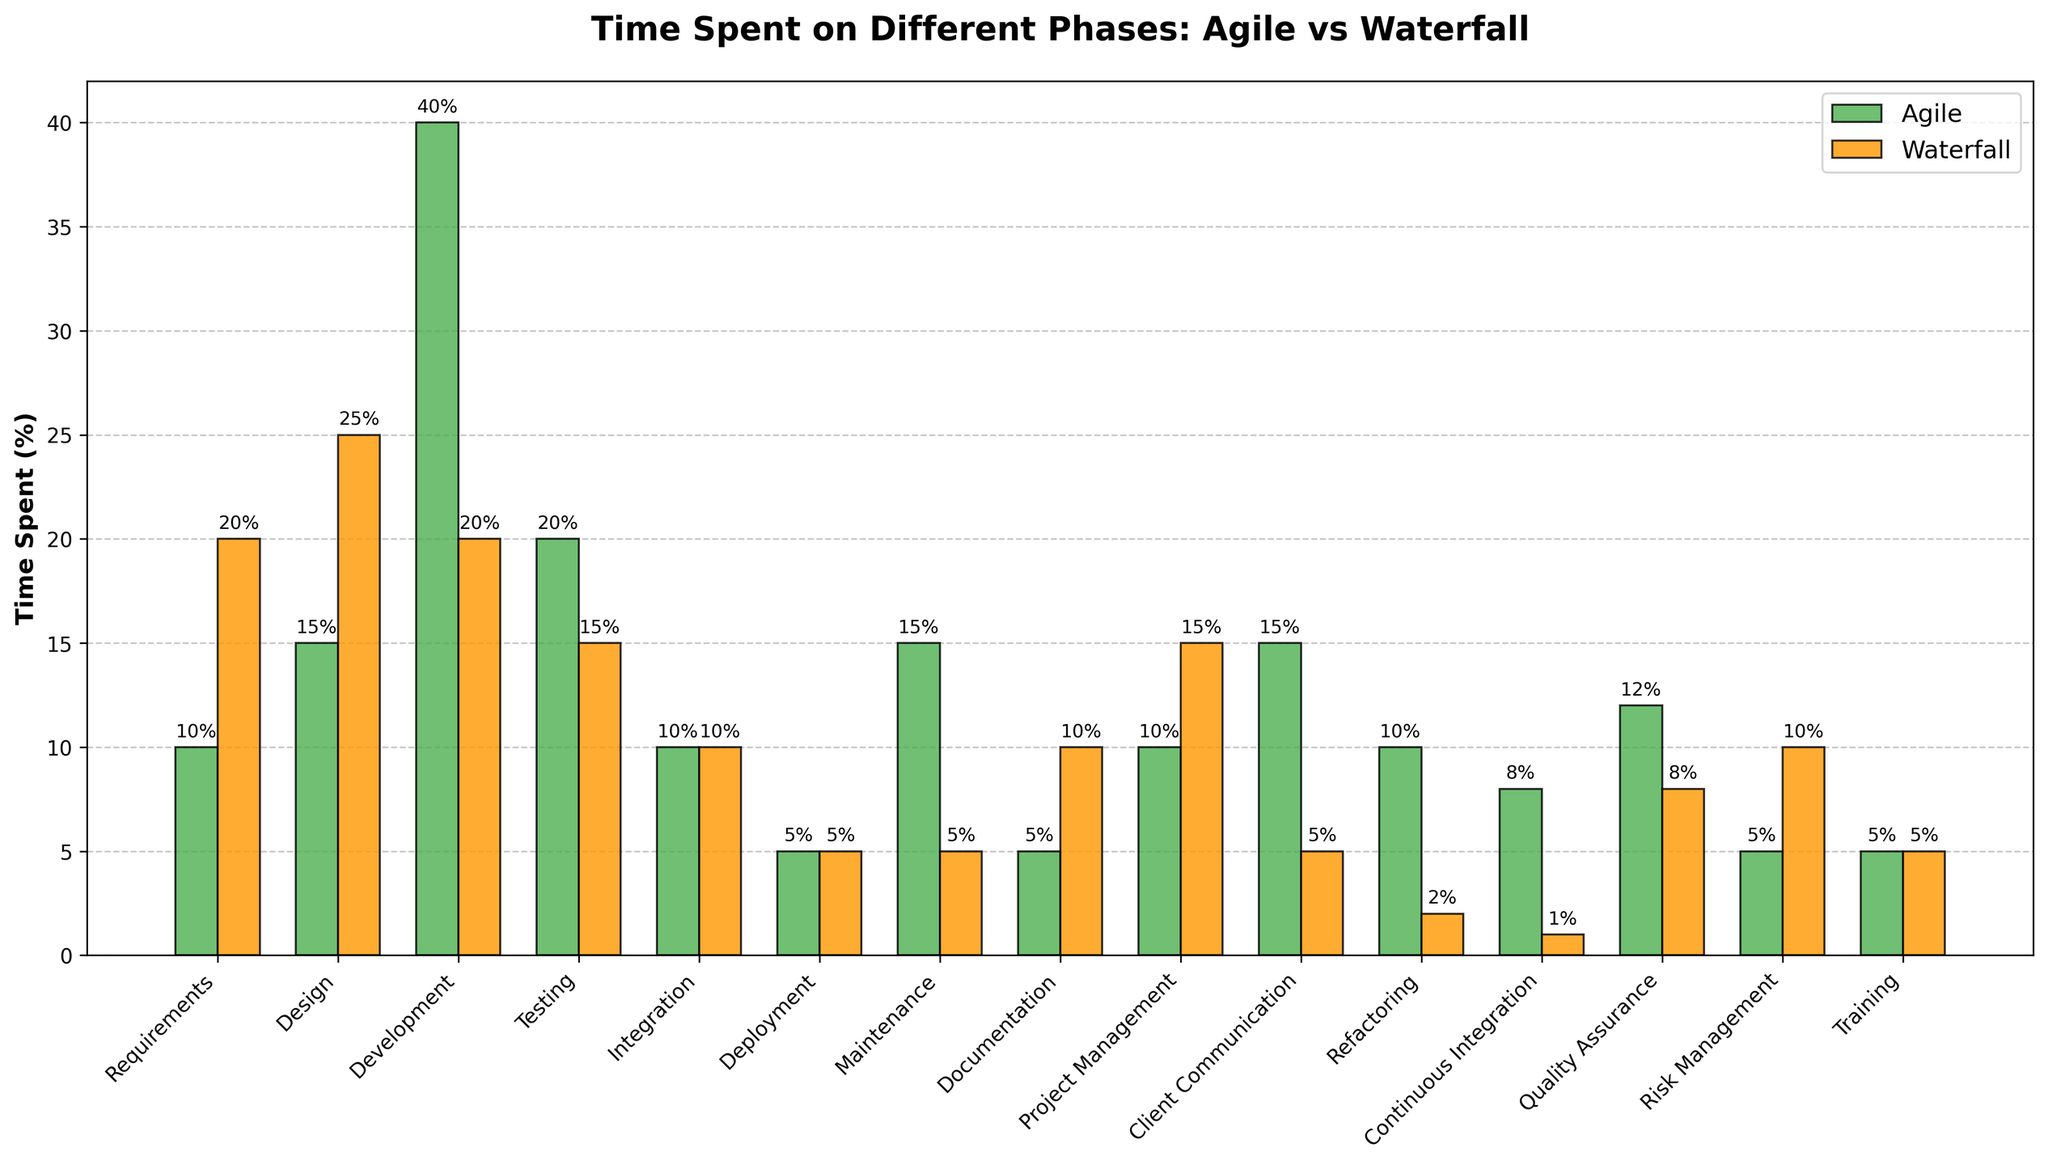Which phase spends the least amount of time in Agile? Looking at the bars for Agile (colored green), the shortest bar is for the Deployment phase.
Answer: Deployment Which methodology spends more time on Design? Comparing the Design phase bars, the bar for Waterfall (orange) is taller than the bar for Agile (green).
Answer: Waterfall How much more time is spent on Maintenance in Agile compared to Waterfall? The Agile bar for Maintenance shows 15%, while the Waterfall bar shows 5%. The difference is 15% - 5%.
Answer: 10% Which phase has equal time spent in both methodologies? The Integration and Deployment phases have bars of the same height for Agile and Waterfall.
Answer: Integration and Deployment What is the total percentage of time spent on Development and Testing in Agile? Adding the values from the Agile bars for Development (40%) and Testing (20%) gives 40% + 20%.
Answer: 60% Which methodology allocates more time to Risk Management? The Risk Management phase bar for Waterfall (orange) is taller than the Agile bar (green).
Answer: Waterfall How much more time is spent on Documentation in Waterfall compared to Agile? The Agile bar for Documentation shows 5%, while the Waterfall bar shows 10%. The difference is 10% - 5%.
Answer: 5% Which phase has the most significant allocation of time in Agile? The Agile bar for Development is the tallest at 40%, indicating the highest time allocation.
Answer: Development How much time is spent on Client Communication in both methodologies combined? The Agile bar for Client Communication shows 15%, and the Waterfall bar shows 5%. Adding these values gives 15% + 5%.
Answer: 20% What is the difference in time spent on Continuous Integration between Agile and Waterfall? The Agile bar for Continuous Integration shows 8%, while the Waterfall bar shows 1%. The difference is 8% - 1%.
Answer: 7% 